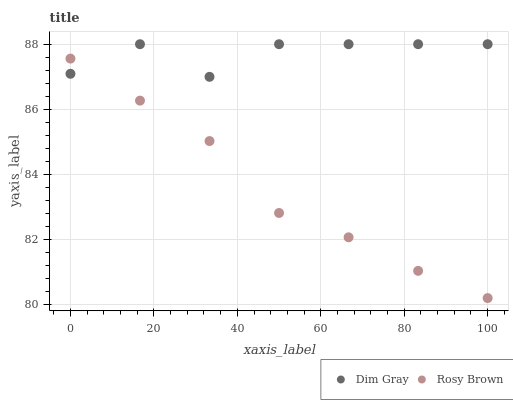Does Rosy Brown have the minimum area under the curve?
Answer yes or no. Yes. Does Dim Gray have the maximum area under the curve?
Answer yes or no. Yes. Does Dim Gray have the minimum area under the curve?
Answer yes or no. No. Is Rosy Brown the smoothest?
Answer yes or no. Yes. Is Dim Gray the roughest?
Answer yes or no. Yes. Is Dim Gray the smoothest?
Answer yes or no. No. Does Rosy Brown have the lowest value?
Answer yes or no. Yes. Does Dim Gray have the lowest value?
Answer yes or no. No. Does Dim Gray have the highest value?
Answer yes or no. Yes. Does Dim Gray intersect Rosy Brown?
Answer yes or no. Yes. Is Dim Gray less than Rosy Brown?
Answer yes or no. No. Is Dim Gray greater than Rosy Brown?
Answer yes or no. No. 